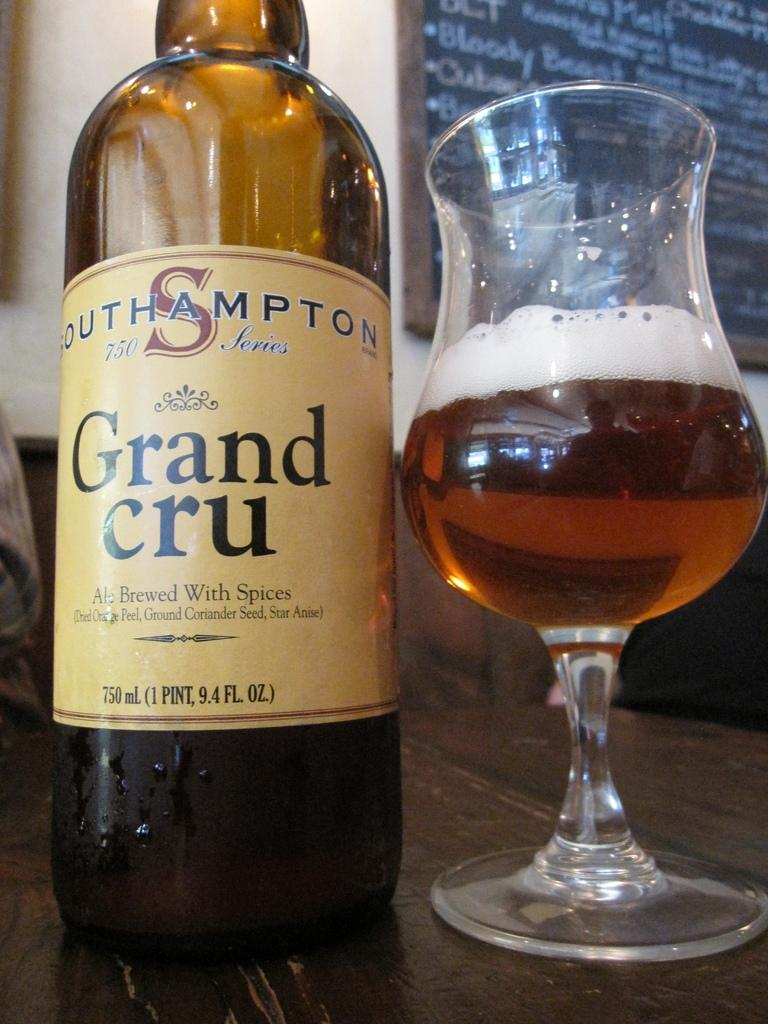<image>
Offer a succinct explanation of the picture presented. a bottle of Grand Cru sitting next to a glass half full of brown liquid 